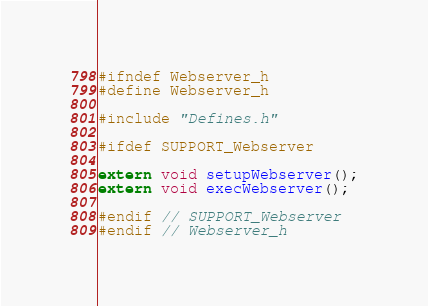<code> <loc_0><loc_0><loc_500><loc_500><_C_>#ifndef Webserver_h
#define Webserver_h

#include "Defines.h"

#ifdef SUPPORT_Webserver

extern void setupWebserver();
extern void execWebserver();

#endif // SUPPORT_Webserver
#endif // Webserver_h

</code> 